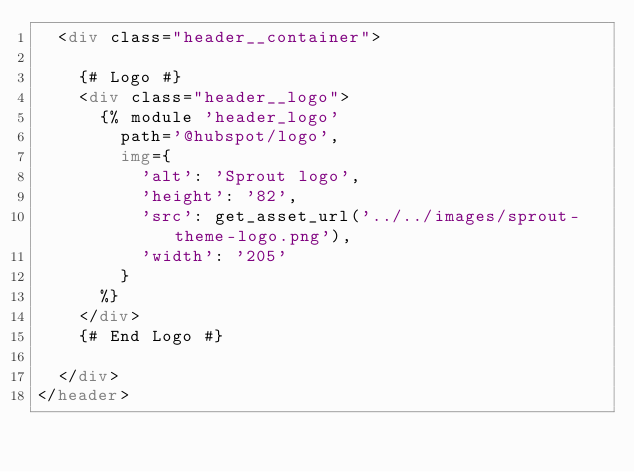<code> <loc_0><loc_0><loc_500><loc_500><_HTML_>  <div class="header__container">

    {# Logo #}
    <div class="header__logo">
      {% module 'header_logo'
        path='@hubspot/logo',
        img={
          'alt': 'Sprout logo',
          'height': '82',
          'src': get_asset_url('../../images/sprout-theme-logo.png'),
          'width': '205'
        }
      %}
    </div>
    {# End Logo #}

  </div>
</header></code> 